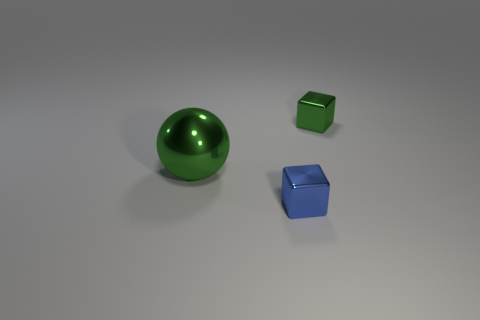Is there anything else that is the same color as the big shiny ball?
Your response must be concise. Yes. The metal object that is both behind the blue shiny cube and in front of the green cube is what color?
Offer a terse response. Green. There is a thing that is in front of the ball; does it have the same size as the big green metallic ball?
Your response must be concise. No. Is the number of metallic cubes that are left of the green cube greater than the number of large green balls?
Provide a short and direct response. No. Does the large green shiny thing have the same shape as the small green shiny thing?
Your answer should be very brief. No. What size is the green block?
Ensure brevity in your answer.  Small. Is the number of balls that are in front of the big green metallic thing greater than the number of blocks that are to the left of the tiny blue shiny thing?
Provide a succinct answer. No. Are there any tiny blue metal objects in front of the blue thing?
Provide a succinct answer. No. Is there a purple block of the same size as the green sphere?
Ensure brevity in your answer.  No. What is the color of the tiny object that is made of the same material as the blue block?
Your answer should be very brief. Green. 